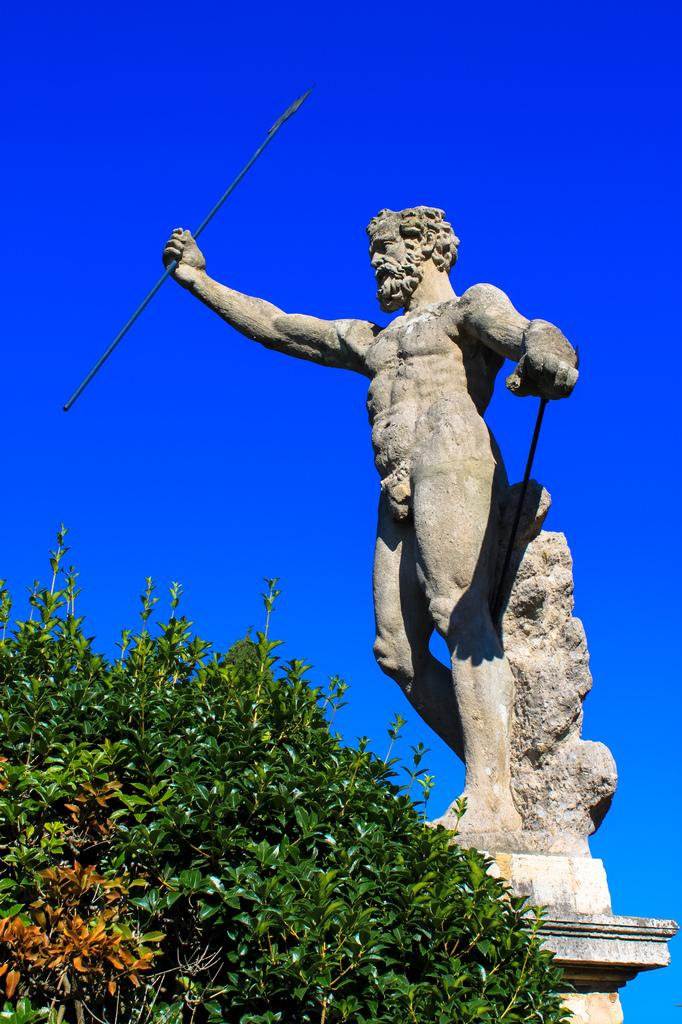What is the main subject of the image? There is a statue of a person in the image. What other object can be seen in the image? There is a plant in the image. What is visible at the top of the image? The sky is visible at the top of the image. How many seeds can be seen in the image? There are no seeds present in the image. What event is causing the statue to blow away in the image? There is no event causing the statue to blow away in the image; it is stationary. 